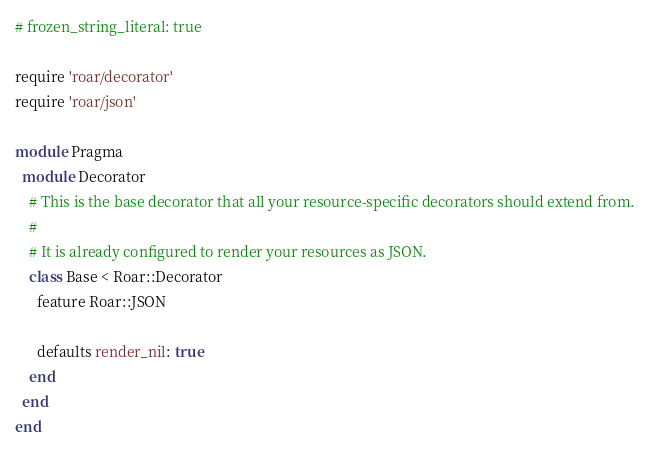<code> <loc_0><loc_0><loc_500><loc_500><_Ruby_># frozen_string_literal: true

require 'roar/decorator'
require 'roar/json'

module Pragma
  module Decorator
    # This is the base decorator that all your resource-specific decorators should extend from.
    #
    # It is already configured to render your resources as JSON.
    class Base < Roar::Decorator
      feature Roar::JSON

      defaults render_nil: true
    end
  end
end
</code> 